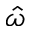Convert formula to latex. <formula><loc_0><loc_0><loc_500><loc_500>\hat { \omega }</formula> 